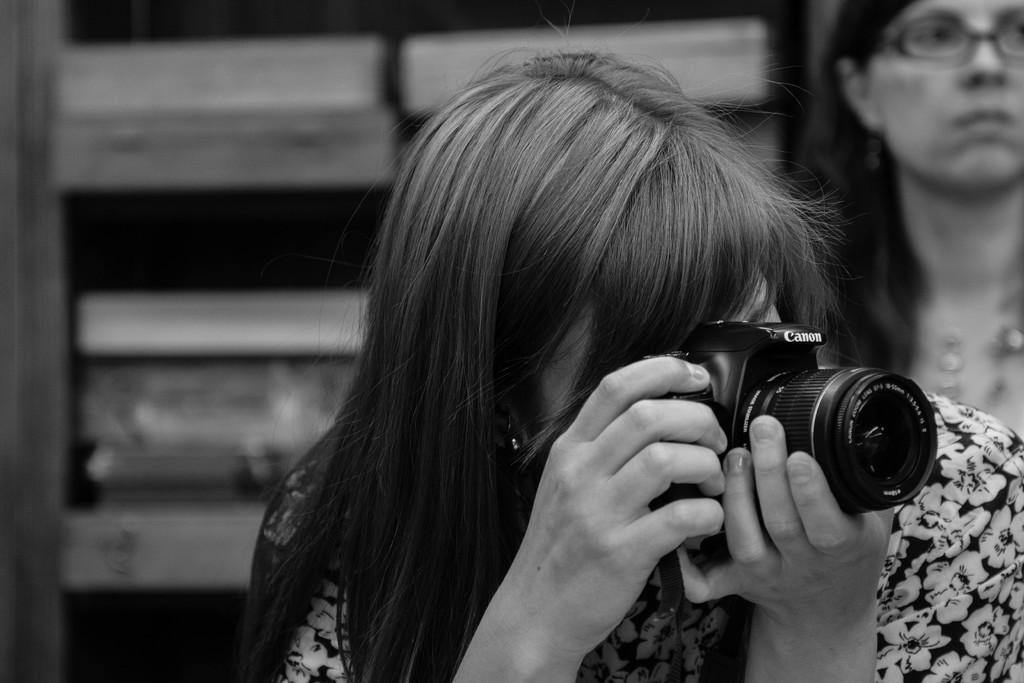How many people are in the image? There are two women in the image. What is one of the women holding? One of the women is holding a camera. What type of riddle is the woman holding in the image? There is no riddle present in the image; one of the women is holding a camera. 